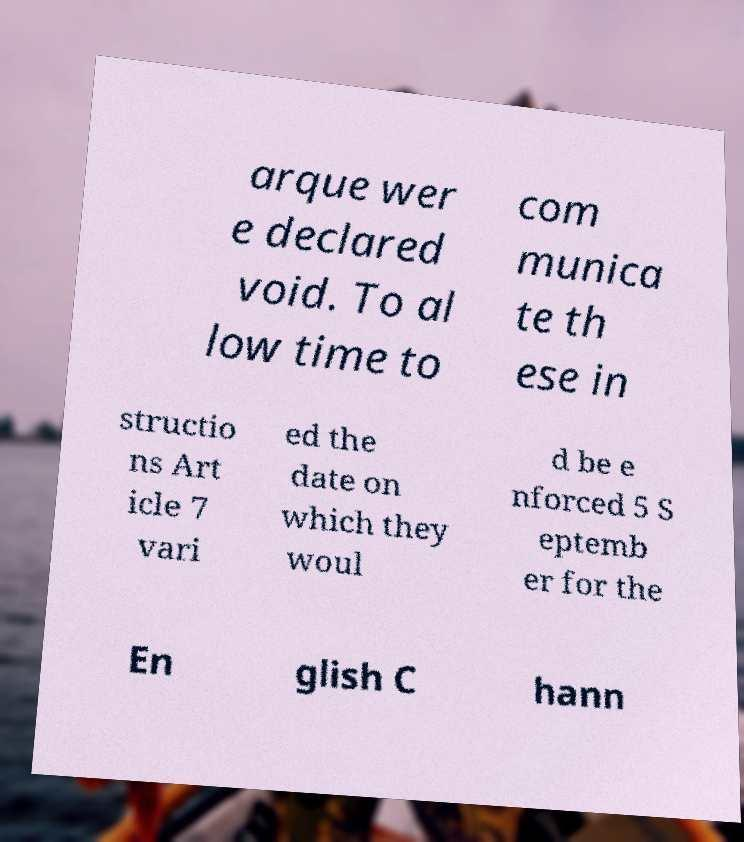Could you assist in decoding the text presented in this image and type it out clearly? arque wer e declared void. To al low time to com munica te th ese in structio ns Art icle 7 vari ed the date on which they woul d be e nforced 5 S eptemb er for the En glish C hann 